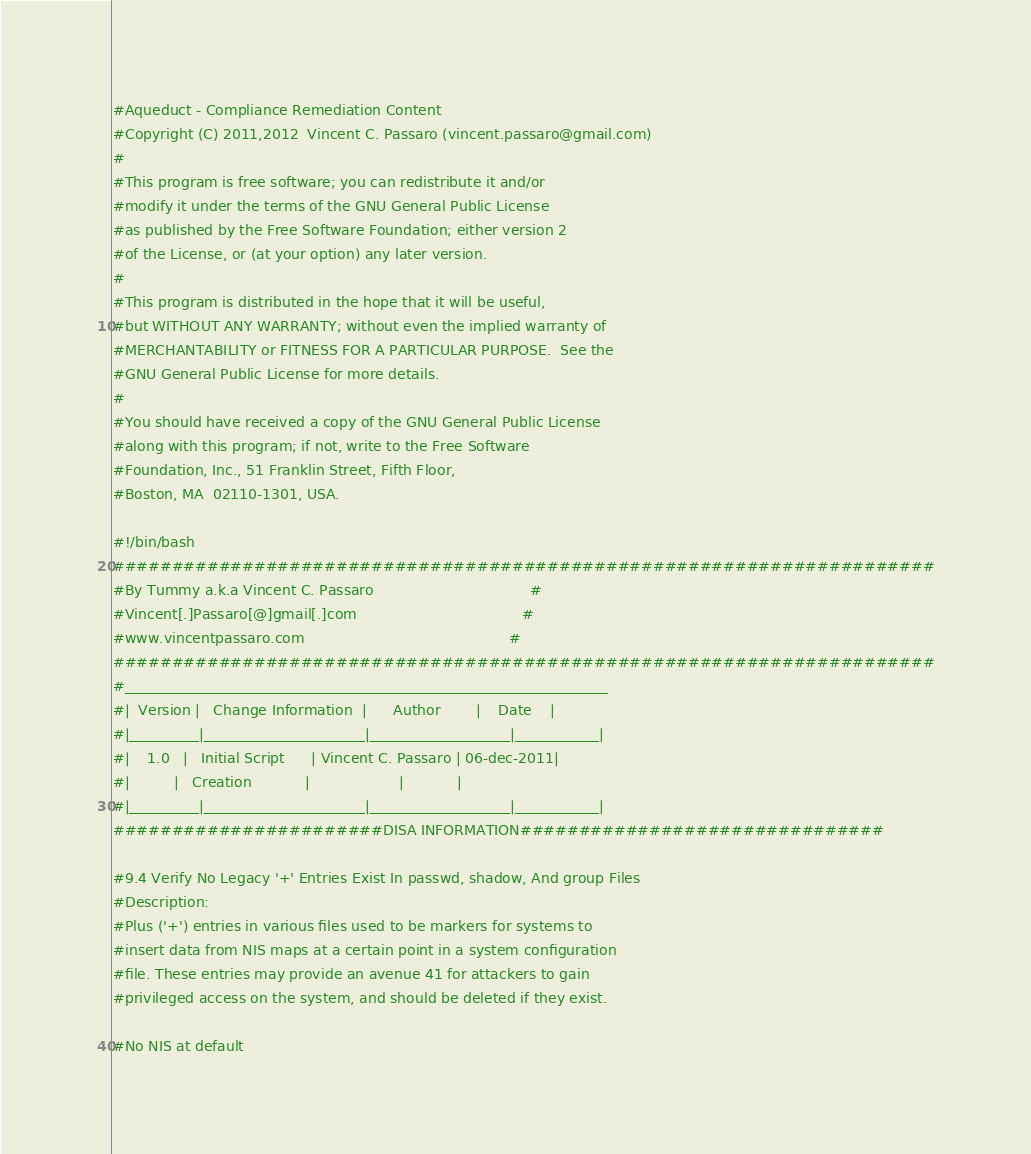Convert code to text. <code><loc_0><loc_0><loc_500><loc_500><_Bash_>#Aqueduct - Compliance Remediation Content
#Copyright (C) 2011,2012  Vincent C. Passaro (vincent.passaro@gmail.com)
#
#This program is free software; you can redistribute it and/or
#modify it under the terms of the GNU General Public License
#as published by the Free Software Foundation; either version 2
#of the License, or (at your option) any later version.
#
#This program is distributed in the hope that it will be useful,
#but WITHOUT ANY WARRANTY; without even the implied warranty of
#MERCHANTABILITY or FITNESS FOR A PARTICULAR PURPOSE.  See the
#GNU General Public License for more details.
#
#You should have received a copy of the GNU General Public License
#along with this program; if not, write to the Free Software
#Foundation, Inc., 51 Franklin Street, Fifth Floor,
#Boston, MA  02110-1301, USA.

#!/bin/bash
######################################################################
#By Tummy a.k.a Vincent C. Passaro                                   #
#Vincent[.]Passaro[@]gmail[.]com                                     #
#www.vincentpassaro.com                                              #
######################################################################
#_____________________________________________________________________
#|  Version |   Change Information  |      Author        |    Date    |
#|__________|_______________________|____________________|____________|
#|    1.0   |   Initial Script      | Vincent C. Passaro | 06-dec-2011|
#|          |   Creation            |                    |            |
#|__________|_______________________|____________________|____________|
#######################DISA INFORMATION###############################

#9.4 Verify No Legacy '+' Entries Exist In passwd, shadow, And group Files
#Description:
#Plus ('+') entries in various files used to be markers for systems to 
#insert data from NIS maps at a certain point in a system configuration 
#file. These entries may provide an avenue 41 for attackers to gain 
#privileged access on the system, and should be deleted if they exist.

#No NIS at default</code> 